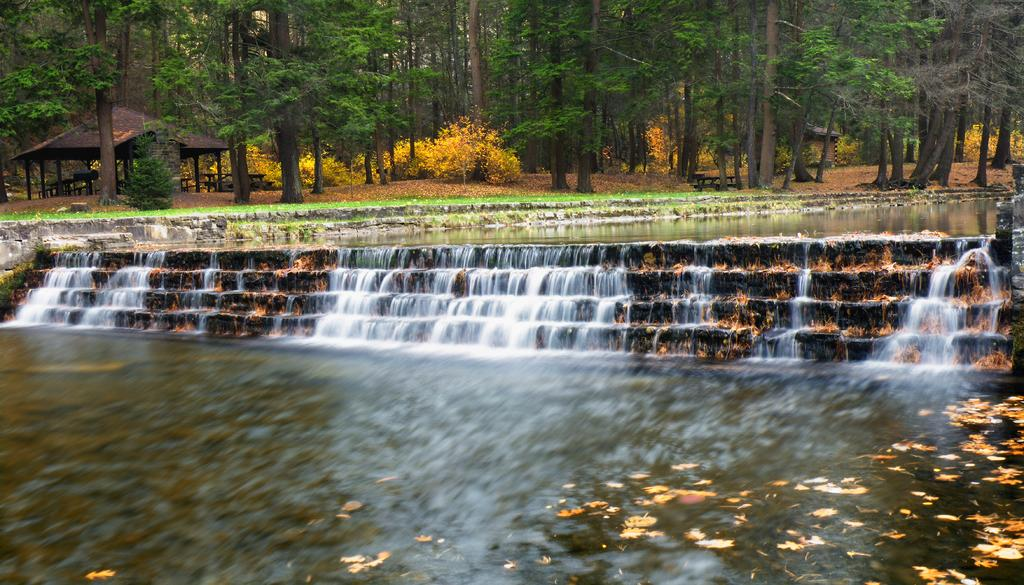What is located in the middle of the image? There are stairs in the middle of the image. What can be seen in the background of the image? There are many trees and plants in the background. What is visible on the left side of the image? There is a shed on the left side of the image. Can you describe the water in the image? The water is visible in the image, but its exact location or purpose is not specified. What type of cat can be seen playing with a hose in the image? There is no cat or hose present in the image. What is the air quality like in the image? The provided facts do not give any information about the air quality in the image. 